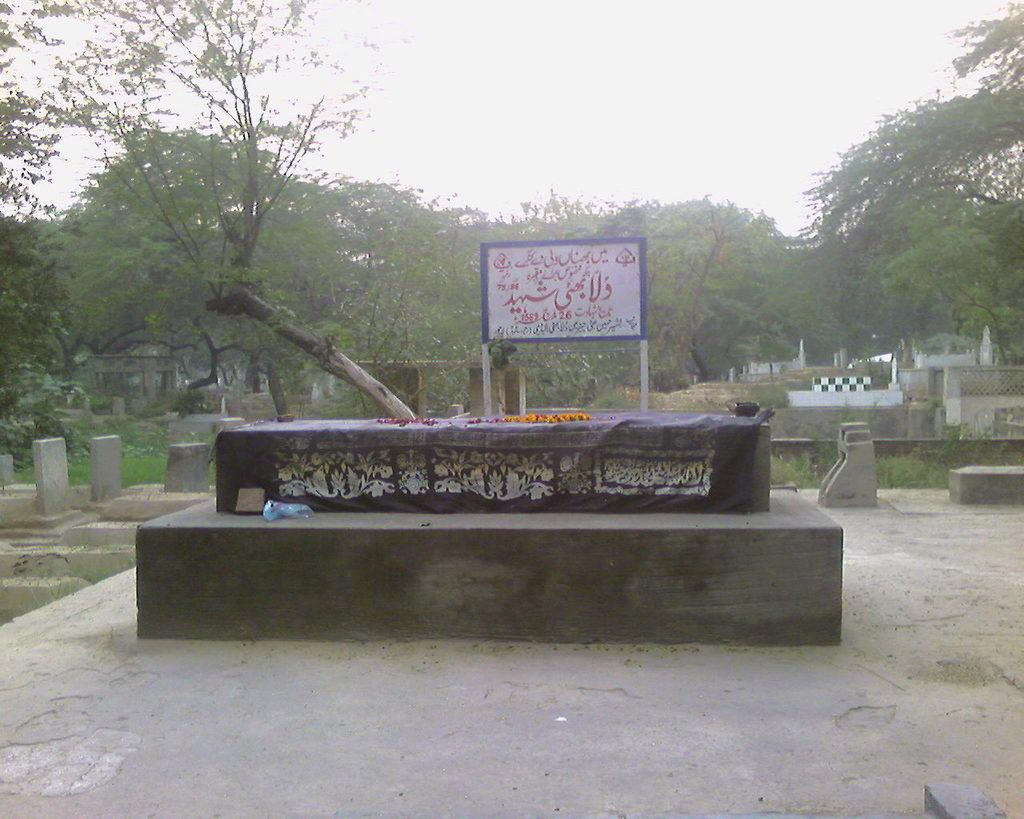What type of structure can be seen in the image? There are graves in the image. What type of material is visible in the image? There is cloth visible in the image. What type of decoration is present in the image? There is a garland in the image. What is placed on one of the graves in the image? There are objects on a grave in the image. What type of natural feature is present in the image? There are trees in the image. What is visible in the background of the image? The sky is visible in the image. What type of riddle can be solved by looking at the cherries in the image? There are no cherries present in the image, so no riddle can be solved by looking at them. What type of lipstick can be seen on the stone in the image? There is no lipstick or any indication of lips on the stone in the image. 